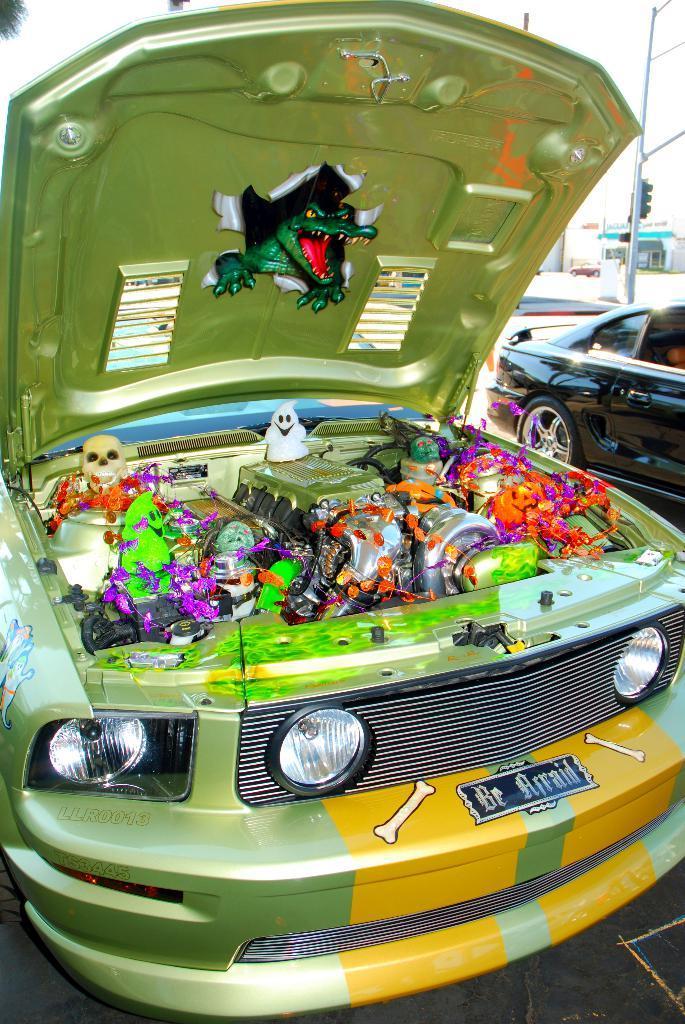Can you describe this image briefly? In this picture we can see few cars, in the background we can find few buildings and a pole. 